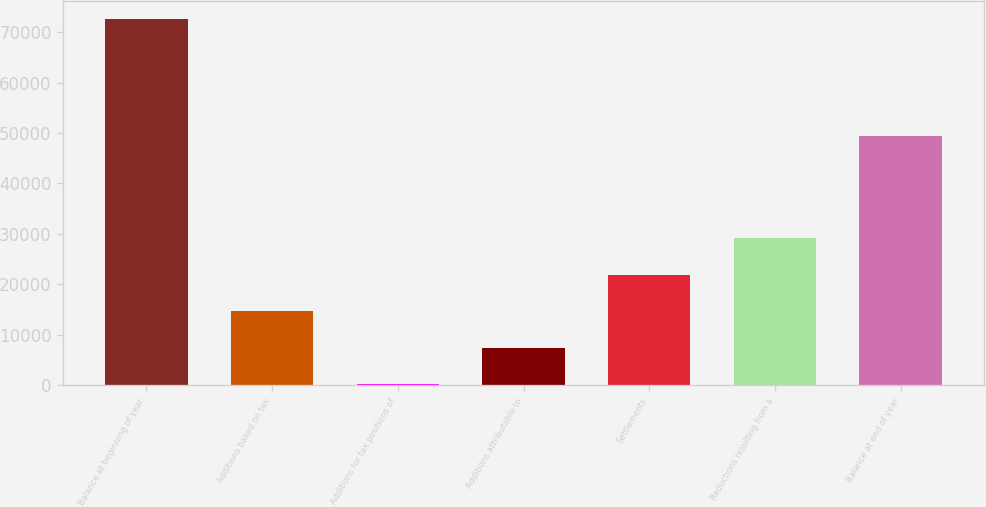<chart> <loc_0><loc_0><loc_500><loc_500><bar_chart><fcel>Balance at beginning of year<fcel>Additions based on tax<fcel>Additions for tax positions of<fcel>Additions attributable to<fcel>Settlements<fcel>Reductions resulting from a<fcel>Balance at end of year<nl><fcel>72547<fcel>14626.2<fcel>146<fcel>7386.1<fcel>21866.3<fcel>29106.4<fcel>49338<nl></chart> 